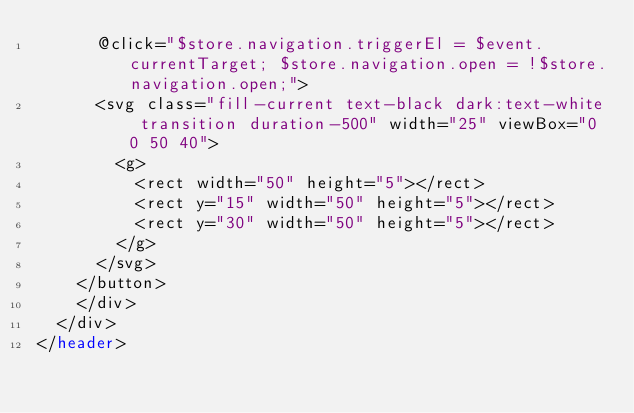Convert code to text. <code><loc_0><loc_0><loc_500><loc_500><_PHP_>      @click="$store.navigation.triggerEl = $event.currentTarget; $store.navigation.open = !$store.navigation.open;">
      <svg class="fill-current text-black dark:text-white transition duration-500" width="25" viewBox="0 0 50 40">
        <g>
          <rect width="50" height="5"></rect>
          <rect y="15" width="50" height="5"></rect>
          <rect y="30" width="50" height="5"></rect>
        </g>
      </svg>
    </button>
    </div>
  </div>
</header>
</code> 